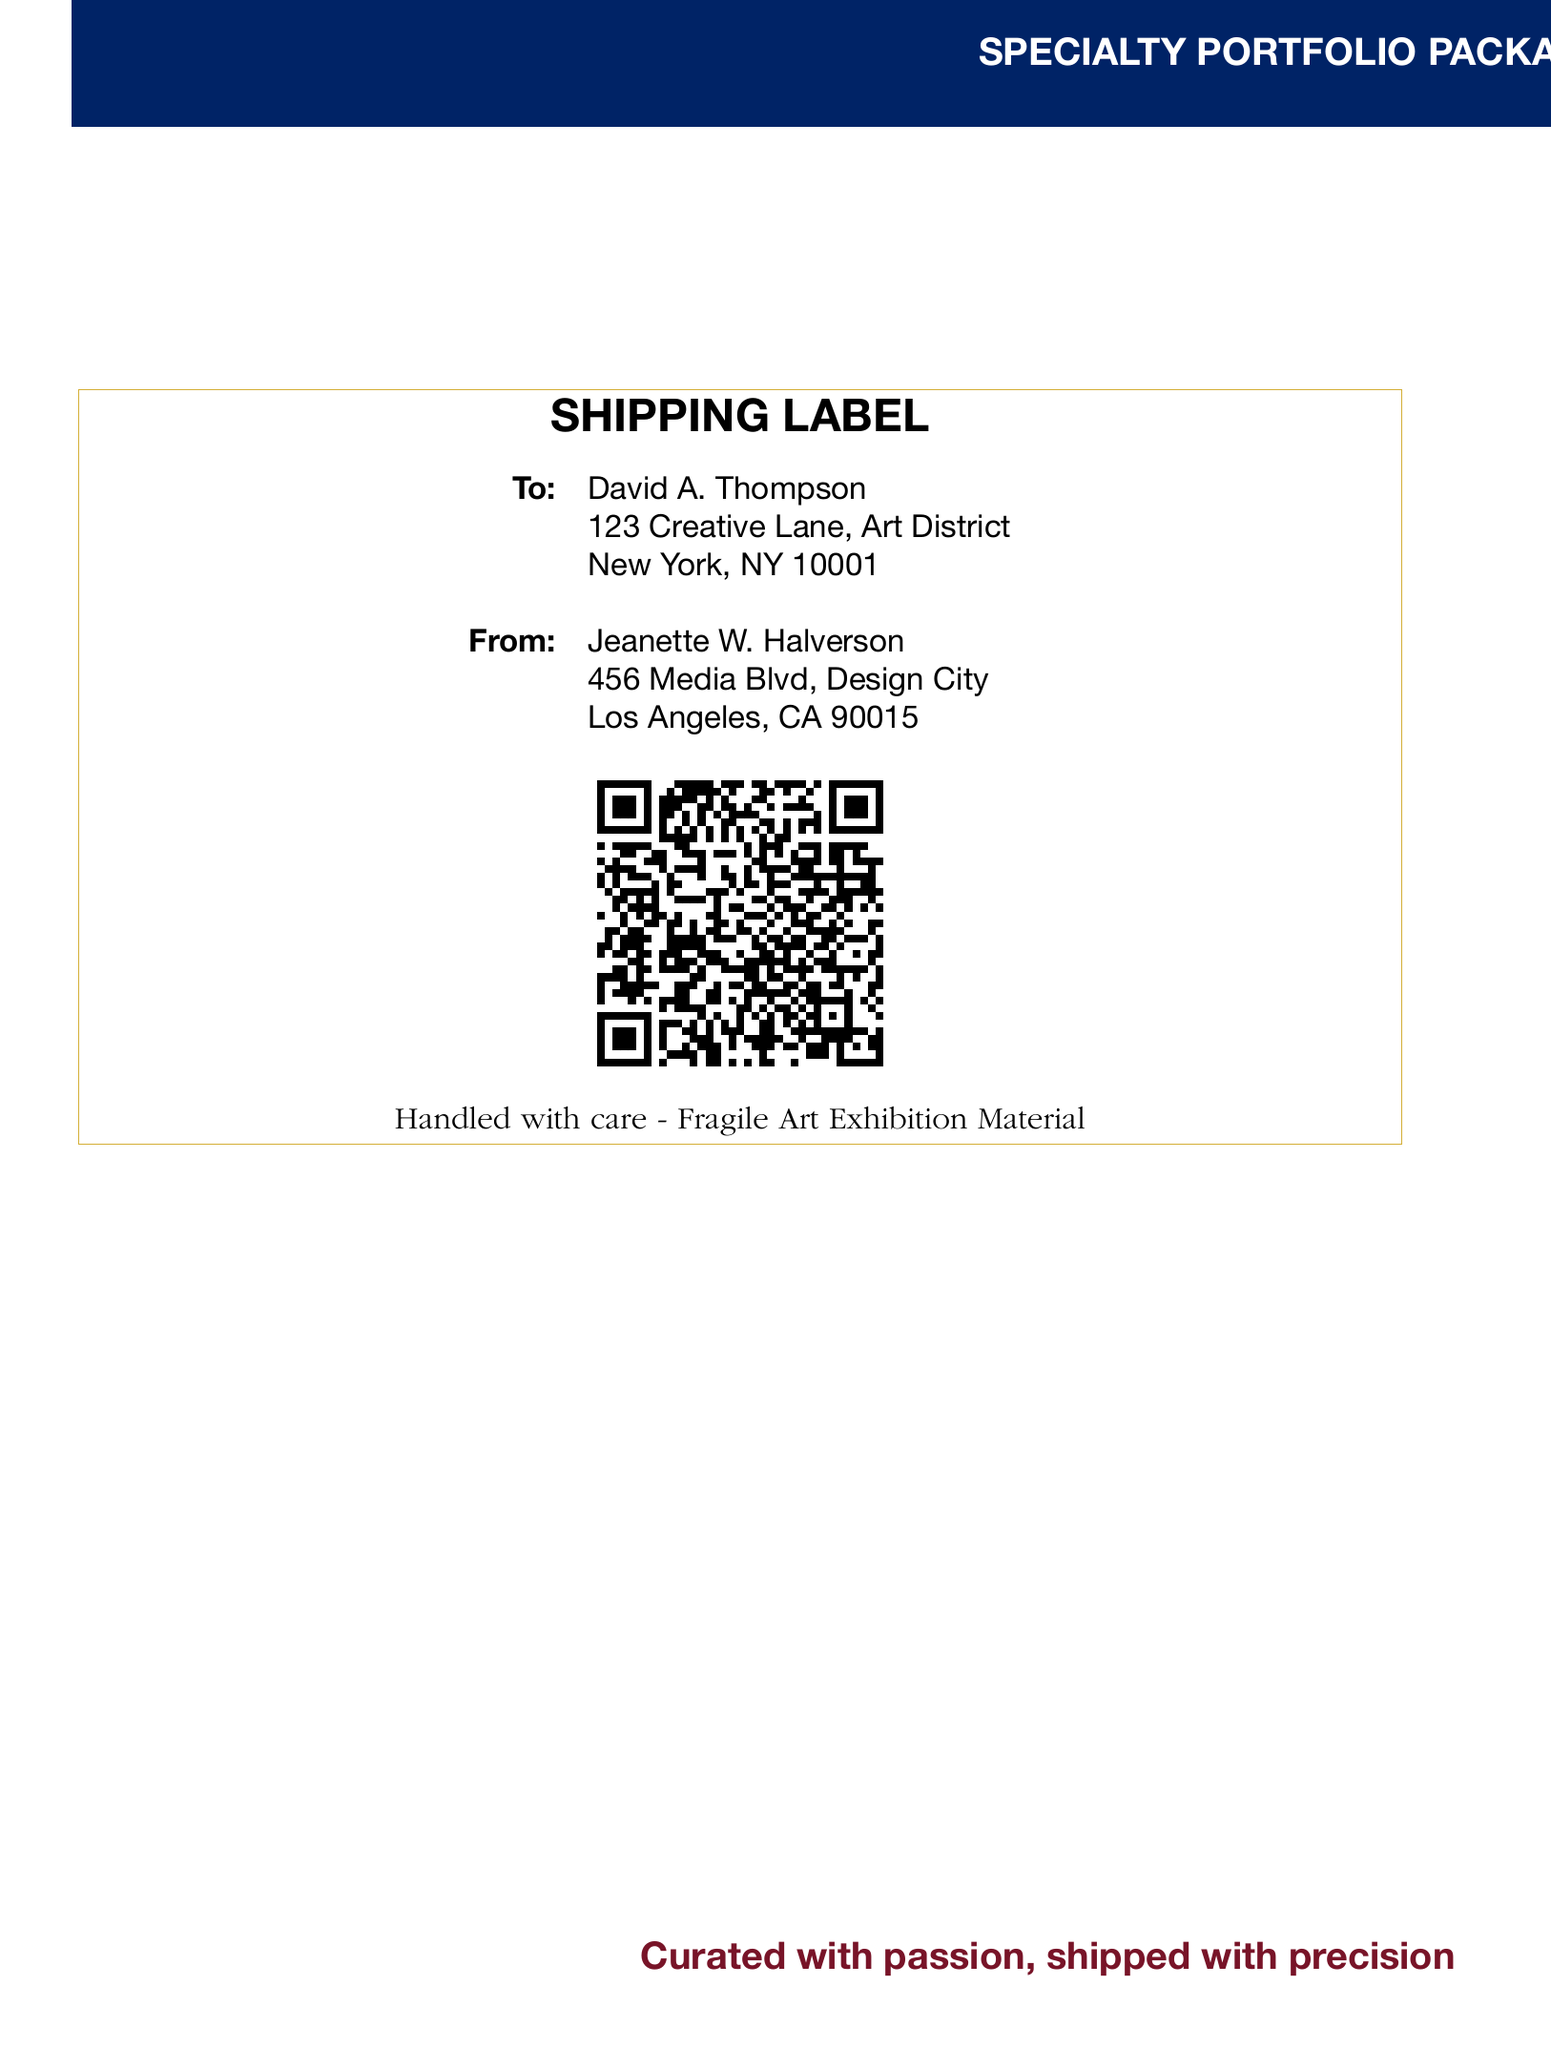What is the exhibition name? The exhibition name is prominently displayed at the top of the document in deep burgundy color.
Answer: CONTEMPORARY VISIONS 2023 What is the recipient's name? The recipient's name is located in the "To" section of the Shipping Label.
Answer: David A. Thompson What is the recipient's address? The address is listed under the recipient's name in the document.
Answer: 123 Creative Lane, Art District, New York, NY 10001 What is the sender's name? The sender's name is located in the "From" section of the Shipping Label.
Answer: Jeanette W. Halverson What design elements are used in the header? The header features a deep burgundy background with white text.
Answer: Deep burgundy background What does the QR code represent? The QR code contains the shipping information for the shipment.
Answer: Shipping information What is the shipping label's message regarding the contents? The message indicates how to handle the contents based on its fragility.
Answer: Handled with care - Fragile Art Exhibition Material What colors are specifically used in the design? The document uses deep burgundy, royal blue, and metallic gold colors.
Answer: Deep burgundy, royal blue, metallic gold What is the tagline at the bottom of the document? The tagline summarizes the care and precision taken in curating and shipping the exhibition materials.
Answer: Curated with passion, shipped with precision 